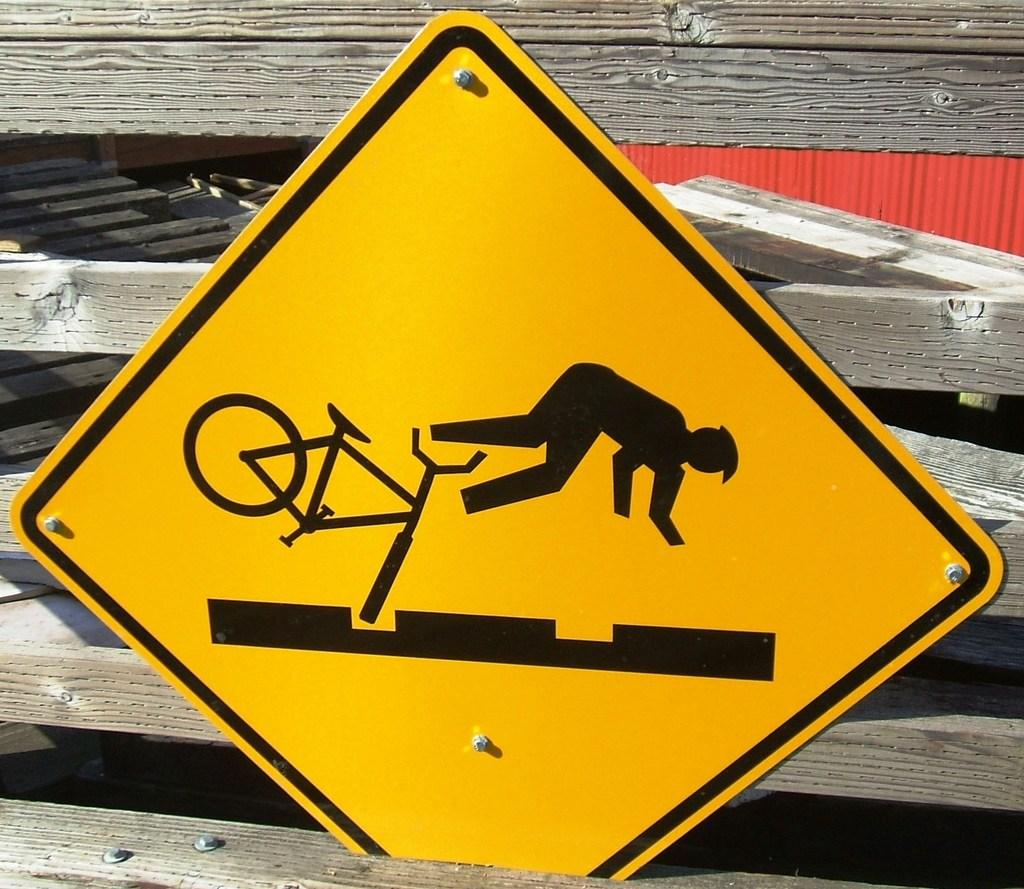What is the main object in the image? There is a sign board in the image. How is the sign board supported? The sign board is attached to wooden bars. What does the sign board depict? The sign board depicts a person falling down with a bicycle. What information does the sign board convey? The sign board indicates the presence of speed breakers on the road. What type of bottle is being held by the person on the sign board? There is no bottle present in the image; the sign board depicts a person falling down with a bicycle. 